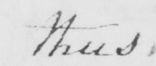Can you tell me what this handwritten text says? thus 